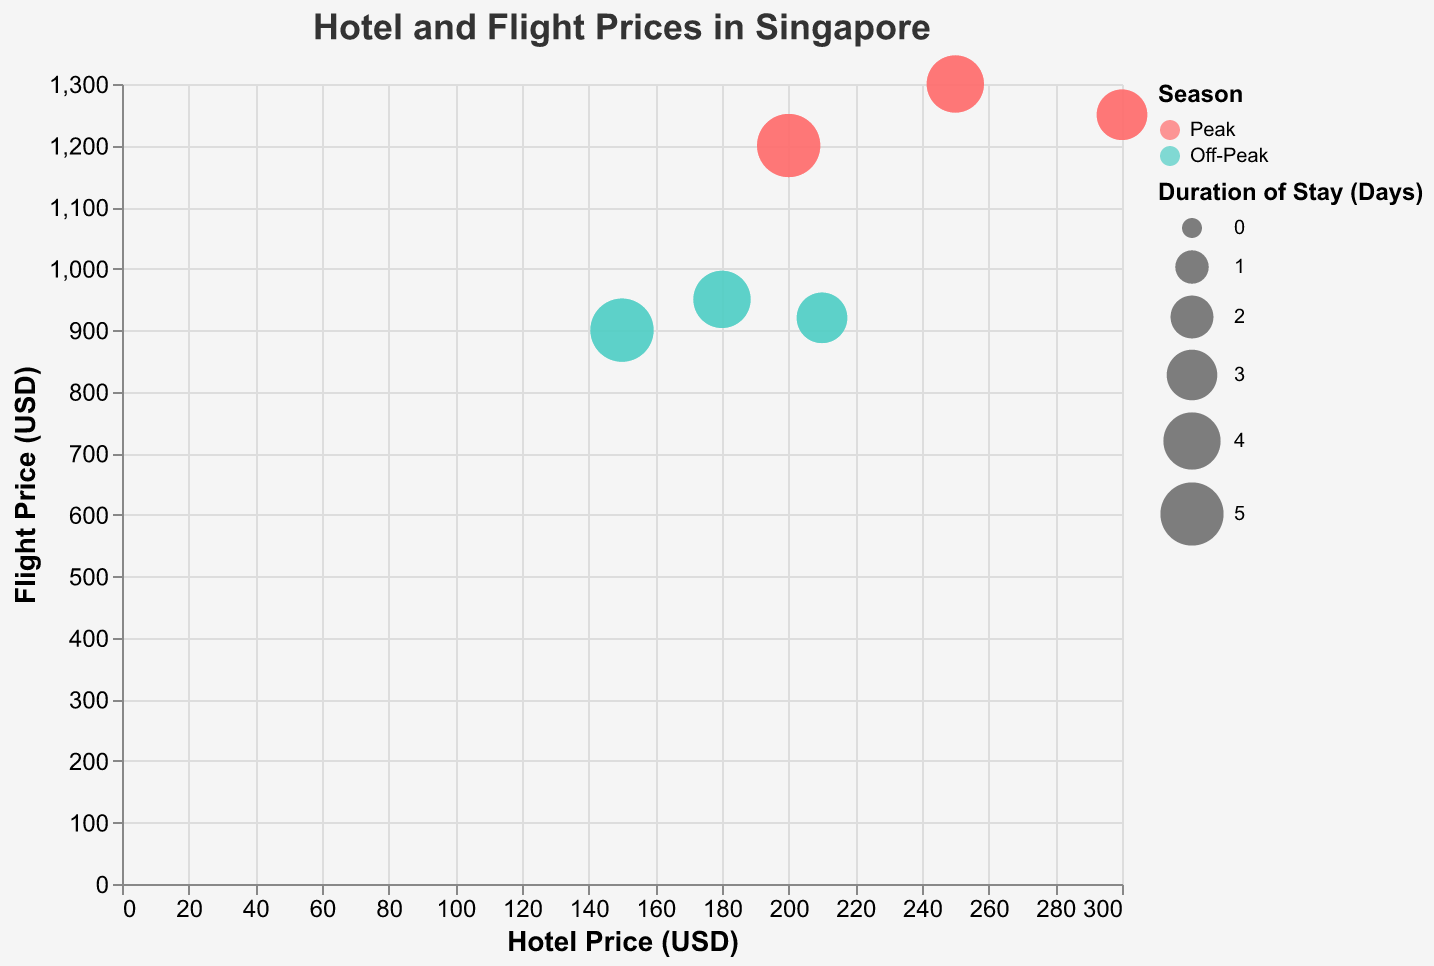What are the peak season hotel prices for Mandarin Orchard, Marina Bay Sands, and Raffles Hotel? The figure shows the hotel prices for "Mandarin Orchard," "Marina Bay Sands," and "Raffles Hotel" during the peak season. Refer to the labeled bubbles for these hotels during the peak season.
Answer: $200, $250, and $300 respectively What is the duration of stay at Mandarin Orchard during both peak and off-peak seasons? The figure has bubbles representing Mandarin Orchard with sizes corresponding to the duration of stay. Look at the sizes during peak and off-peak seasons for Mandarin Orchard.
Answer: 5 days Are flight prices higher during peak or off-peak seasons for Singapore Airlines? Compare the y-axis values (Flight Price in USD) for Singapore Airlines during peak and off-peak seasons.
Answer: Higher during peak season ($1300 vs. $950) Which hotel has the highest price during off-peak season? Refer to the x-axis values for the hotel bubbles during the off-peak season and identify the highest value.
Answer: Raffles Hotel ($210) What is the flight price difference between Qatar Airways during peak and off-peak seasons? Identify the y-axis values for Qatar Airways during peak and off-peak seasons and calculate the difference: ($1250 - $920).
Answer: $330 Which peak season hotel offers accommodation for the longest duration? Look at the size of the bubbles for hotels during peak season, as the size represents the duration of stay.
Answer: Mandarin Orchard (5 days) How does the average hotel price during peak season compare to the average hotel price during off-peak season? Calculate the average hotel price for both seasons. Peak: ($200 + $250 + $300)/3; Off-Peak: ($150 + $180 + $210)/3. Compare the results.
Answer: Peak: $250, Off-Peak: $180 For off-peak season, which entity has the lowest flight price, and what is the price? Refer to the y-axis values for flight bubbles during the off-peak season and identify the lowest value.
Answer: Delta Airlines ($900) What shape represents flight entities in the chart? Look at the legend that includes the shape for flights and hotels to find the shape used for flights.
Answer: Square Is the price difference between peak and off-peak seasons greater for hotels or flights for Marina Bay Sands and Singapore Airlines? Calculate and compare the price differences for both Marina Bay Sands ($250 - $180) and Singapore Airlines ($1300 - $950).
Answer: Flights (Marina Bay Sands: $70, Singapore Airlines: $350) 